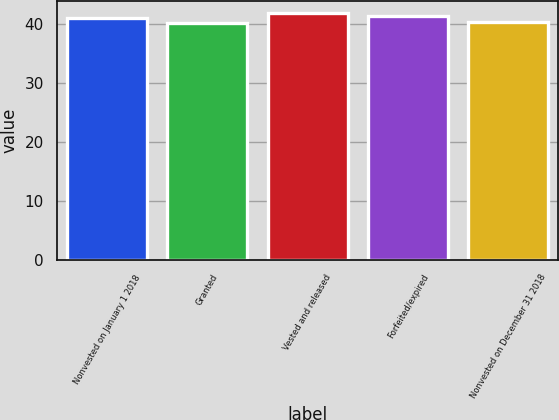<chart> <loc_0><loc_0><loc_500><loc_500><bar_chart><fcel>Nonvested on January 1 2018<fcel>Granted<fcel>Vested and released<fcel>Forfeited/expired<fcel>Nonvested on December 31 2018<nl><fcel>40.99<fcel>40.12<fcel>41.8<fcel>41.32<fcel>40.31<nl></chart> 